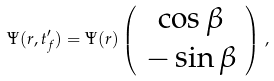Convert formula to latex. <formula><loc_0><loc_0><loc_500><loc_500>\Psi ( r , t ^ { \prime } _ { f } ) = \Psi ( r ) \left ( \begin{array} { c } \cos \beta \\ - \sin \beta \end{array} \right ) \, ,</formula> 